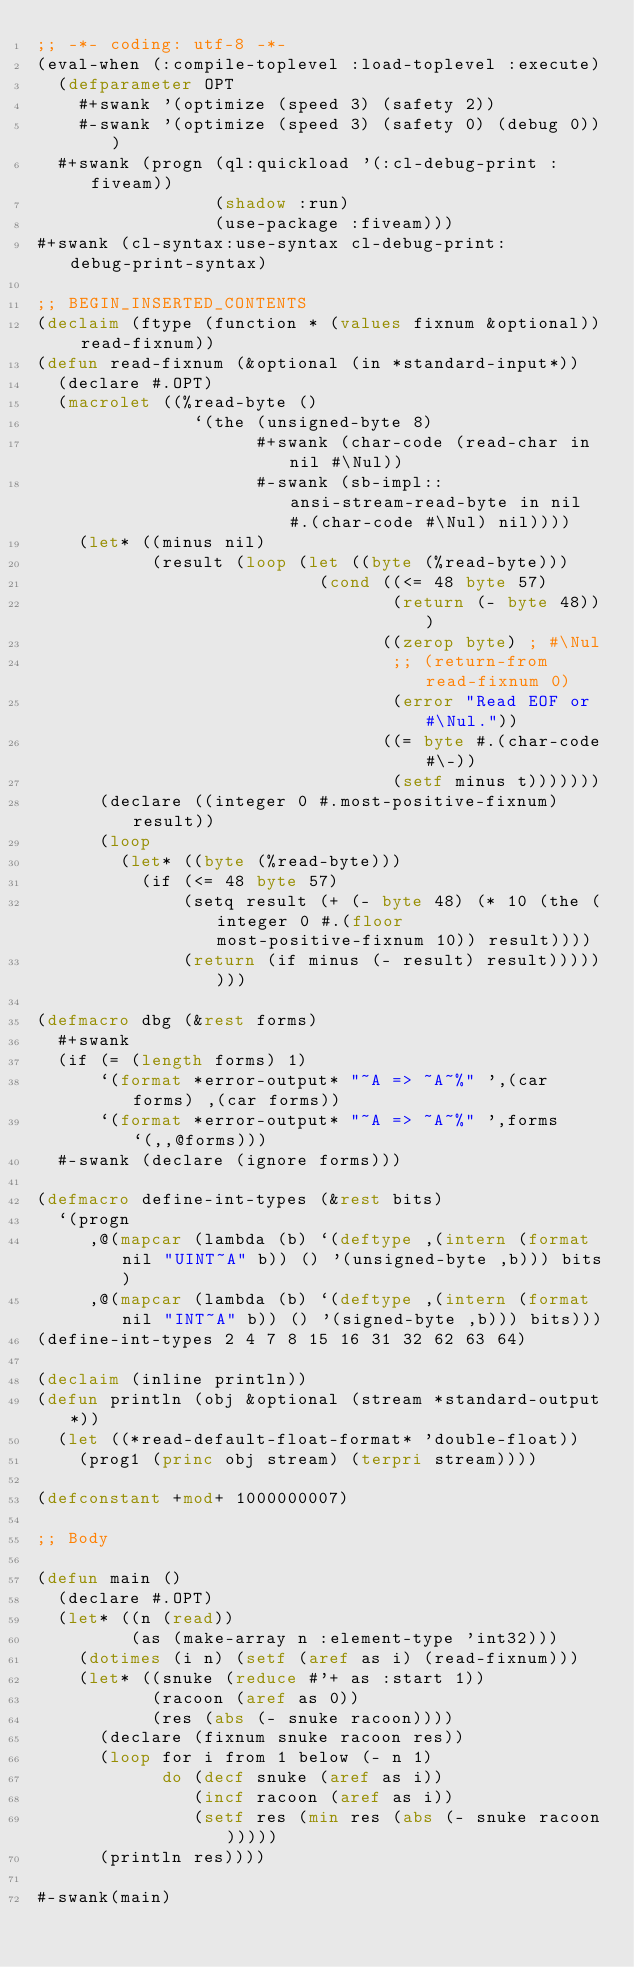<code> <loc_0><loc_0><loc_500><loc_500><_Lisp_>;; -*- coding: utf-8 -*-
(eval-when (:compile-toplevel :load-toplevel :execute)
  (defparameter OPT
    #+swank '(optimize (speed 3) (safety 2))
    #-swank '(optimize (speed 3) (safety 0) (debug 0)))
  #+swank (progn (ql:quickload '(:cl-debug-print :fiveam))
                 (shadow :run)
                 (use-package :fiveam)))
#+swank (cl-syntax:use-syntax cl-debug-print:debug-print-syntax)

;; BEGIN_INSERTED_CONTENTS
(declaim (ftype (function * (values fixnum &optional)) read-fixnum))
(defun read-fixnum (&optional (in *standard-input*))
  (declare #.OPT)
  (macrolet ((%read-byte ()
               `(the (unsigned-byte 8)
                     #+swank (char-code (read-char in nil #\Nul))
                     #-swank (sb-impl::ansi-stream-read-byte in nil #.(char-code #\Nul) nil))))
    (let* ((minus nil)
           (result (loop (let ((byte (%read-byte)))
                           (cond ((<= 48 byte 57)
                                  (return (- byte 48)))
                                 ((zerop byte) ; #\Nul
                                  ;; (return-from read-fixnum 0)
                                  (error "Read EOF or #\Nul."))
                                 ((= byte #.(char-code #\-))
                                  (setf minus t)))))))
      (declare ((integer 0 #.most-positive-fixnum) result))
      (loop
        (let* ((byte (%read-byte)))
          (if (<= 48 byte 57)
              (setq result (+ (- byte 48) (* 10 (the (integer 0 #.(floor most-positive-fixnum 10)) result))))
              (return (if minus (- result) result))))))))

(defmacro dbg (&rest forms)
  #+swank
  (if (= (length forms) 1)
      `(format *error-output* "~A => ~A~%" ',(car forms) ,(car forms))
      `(format *error-output* "~A => ~A~%" ',forms `(,,@forms)))
  #-swank (declare (ignore forms)))

(defmacro define-int-types (&rest bits)
  `(progn
     ,@(mapcar (lambda (b) `(deftype ,(intern (format nil "UINT~A" b)) () '(unsigned-byte ,b))) bits)
     ,@(mapcar (lambda (b) `(deftype ,(intern (format nil "INT~A" b)) () '(signed-byte ,b))) bits)))
(define-int-types 2 4 7 8 15 16 31 32 62 63 64)

(declaim (inline println))
(defun println (obj &optional (stream *standard-output*))
  (let ((*read-default-float-format* 'double-float))
    (prog1 (princ obj stream) (terpri stream))))

(defconstant +mod+ 1000000007)

;; Body

(defun main ()
  (declare #.OPT)
  (let* ((n (read))
         (as (make-array n :element-type 'int32)))
    (dotimes (i n) (setf (aref as i) (read-fixnum)))
    (let* ((snuke (reduce #'+ as :start 1))
           (racoon (aref as 0))
           (res (abs (- snuke racoon))))
      (declare (fixnum snuke racoon res))
      (loop for i from 1 below (- n 1)
            do (decf snuke (aref as i))
               (incf racoon (aref as i))
               (setf res (min res (abs (- snuke racoon)))))
      (println res))))

#-swank(main)
</code> 